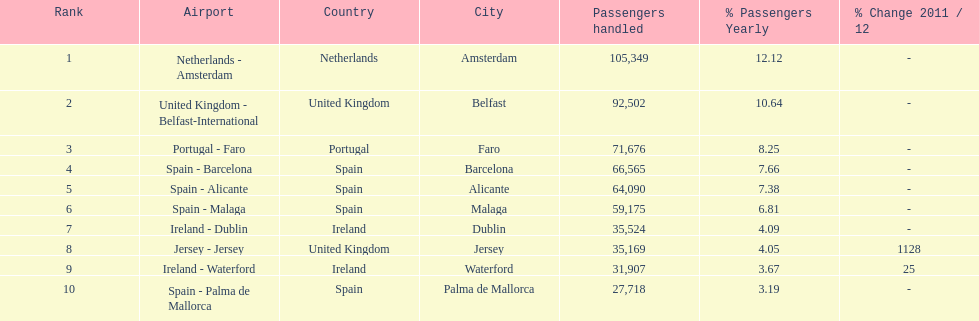How many airports in spain are among the 10 busiest routes to and from london southend airport in 2012? 4. 